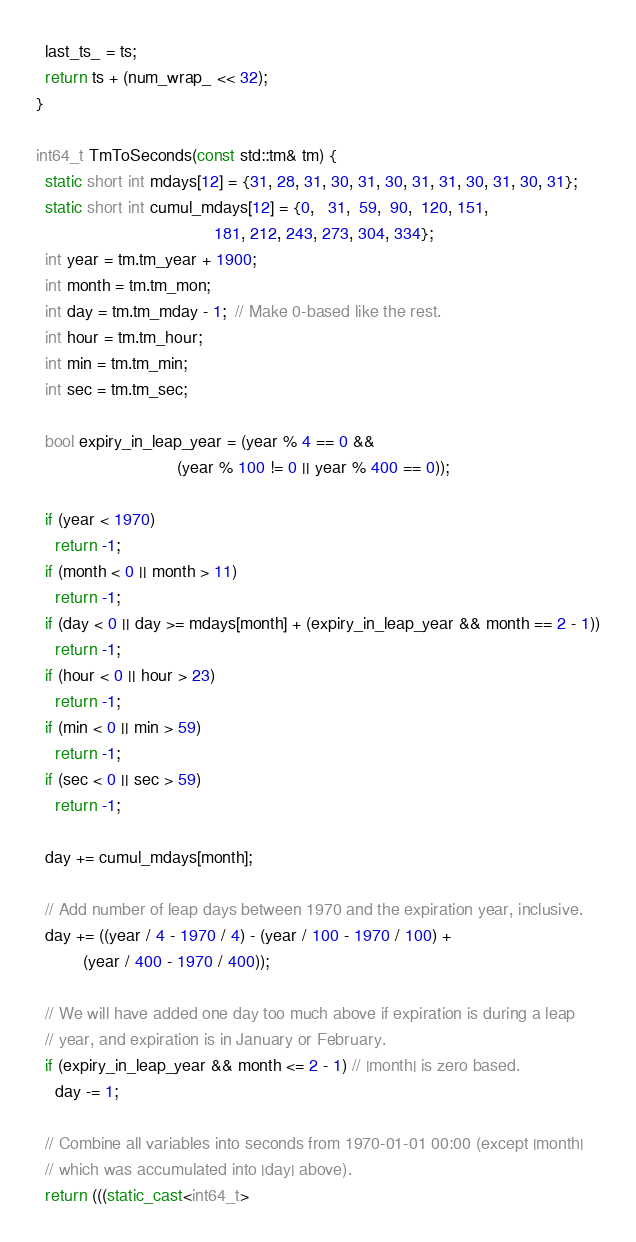<code> <loc_0><loc_0><loc_500><loc_500><_C++_>  last_ts_ = ts;
  return ts + (num_wrap_ << 32);
}

int64_t TmToSeconds(const std::tm& tm) {
  static short int mdays[12] = {31, 28, 31, 30, 31, 30, 31, 31, 30, 31, 30, 31};
  static short int cumul_mdays[12] = {0,   31,  59,  90,  120, 151,
                                      181, 212, 243, 273, 304, 334};
  int year = tm.tm_year + 1900;
  int month = tm.tm_mon;
  int day = tm.tm_mday - 1;  // Make 0-based like the rest.
  int hour = tm.tm_hour;
  int min = tm.tm_min;
  int sec = tm.tm_sec;

  bool expiry_in_leap_year = (year % 4 == 0 &&
                              (year % 100 != 0 || year % 400 == 0));

  if (year < 1970)
    return -1;
  if (month < 0 || month > 11)
    return -1;
  if (day < 0 || day >= mdays[month] + (expiry_in_leap_year && month == 2 - 1))
    return -1;
  if (hour < 0 || hour > 23)
    return -1;
  if (min < 0 || min > 59)
    return -1;
  if (sec < 0 || sec > 59)
    return -1;

  day += cumul_mdays[month];

  // Add number of leap days between 1970 and the expiration year, inclusive.
  day += ((year / 4 - 1970 / 4) - (year / 100 - 1970 / 100) +
          (year / 400 - 1970 / 400));

  // We will have added one day too much above if expiration is during a leap
  // year, and expiration is in January or February.
  if (expiry_in_leap_year && month <= 2 - 1) // |month| is zero based.
    day -= 1;

  // Combine all variables into seconds from 1970-01-01 00:00 (except |month|
  // which was accumulated into |day| above).
  return (((static_cast<int64_t></code> 